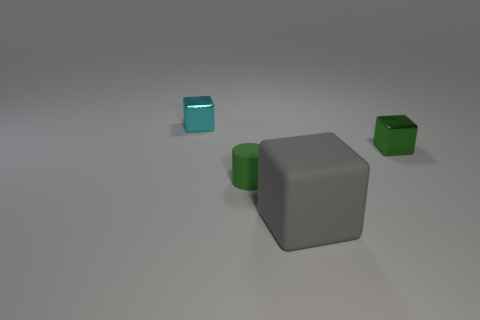What color is the cube that is the same material as the green cylinder? gray 